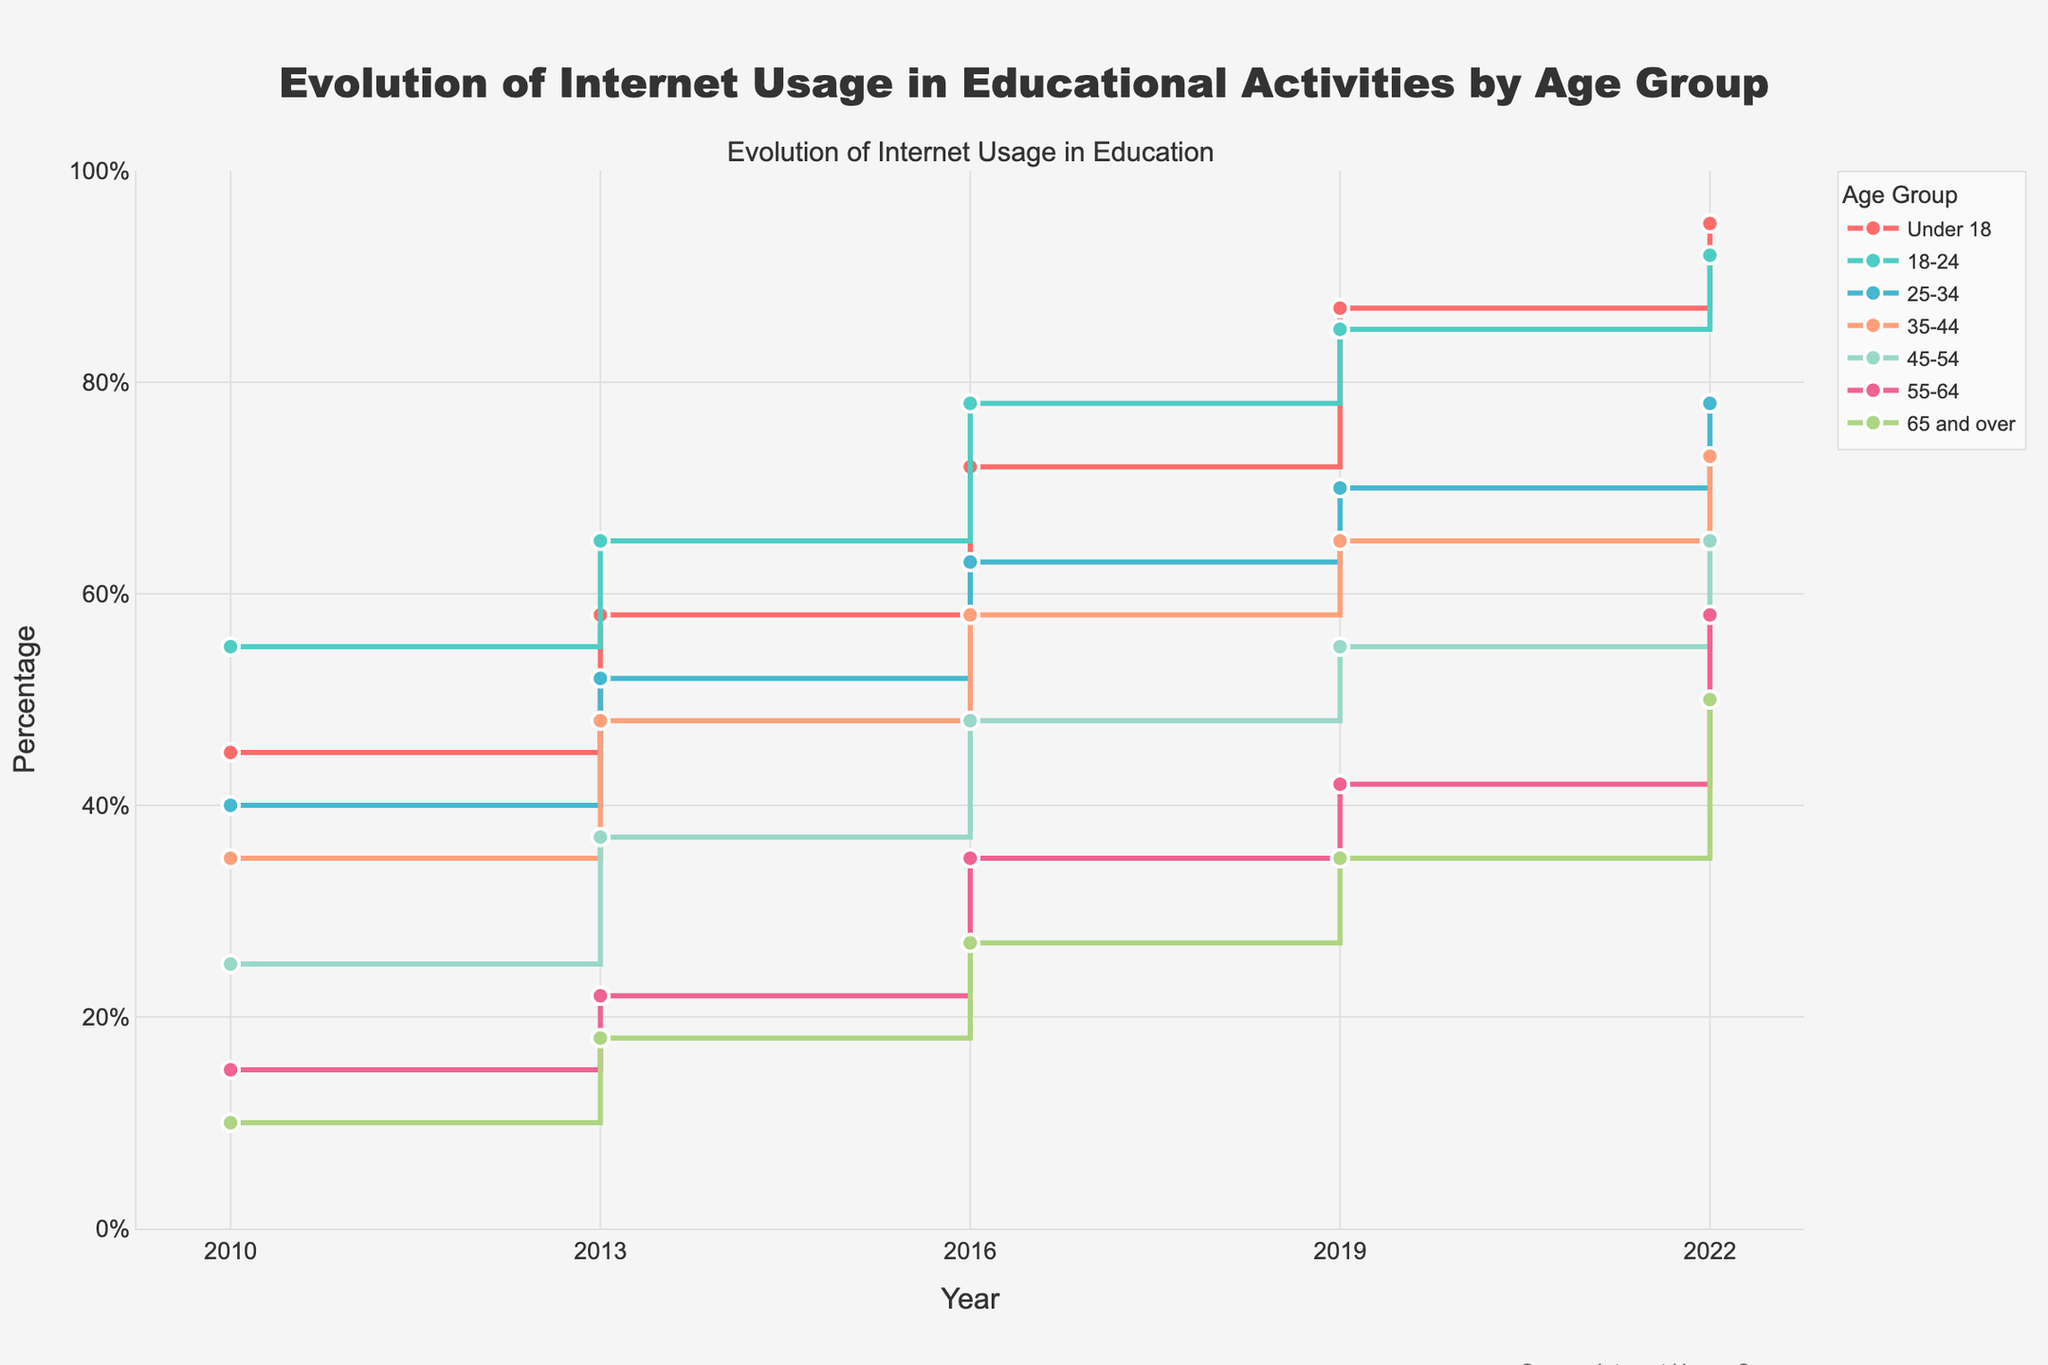What is the title of the plot? The title is located at the top center of the plot. It reads "Evolution of Internet Usage in Educational Activities by Age Group".
Answer: Evolution of Internet Usage in Educational Activities by Age Group What does the y-axis represent? The y-axis represents the percentage of internet usage in educational activities. This is indicated by the y-axis title "Percentage".
Answer: Percentage Which age group had the highest internet usage in 2010? To find this, look at the year 2010 on the x-axis and compare the percentage values for all age groups. The age group 18-24 had the highest percentage at 55%.
Answer: 18-24 How did internet usage change for the age group 25-34 from 2010 to 2022? Find the year 2010 and 2022 on the x-axis and look at the percentages for the age group 25-34. In 2010, it was 40%, and in 2022, it rose to 78%. The change is 78% - 40% = 38%.
Answer: Increased by 38% Which age group had the lowest internet usage in 2019, and what was the percentage? Look at the year 2019 on the x-axis and compare the percentages for all age groups. The age group 65 and over had the lowest percentage at 35%.
Answer: 65 and over with 35% What is the overall trend in internet usage for the age group 55-64 from 2010 to 2022? Find the percentages for the age group 55-64 in each year: 2010 (15%), 2013 (22%), 2016 (35%), 2019 (42%), 2022 (58%). The overall trend shows a continuous increase in internet usage for this age group.
Answer: Increasing In which year did the age group Under 18 surpass 70% in internet usage? Look at the percentages for the age group Under 18. They surpass 70% in 2016 with a percentage of 72%.
Answer: 2016 Between 2013 and 2016, which age group saw the highest increase in internet usage, and what was the increase? Calculate the difference in percentages between 2013 and 2016 for each age group. For Under 18, the increase is 72% - 58% = 14%. For 18-24, it's 78% - 65% = 13%. For 25-34, it's 63% - 52% = 11%. For 35-44, it's 58% - 48% = 10%. For 45-54, it's 48% - 37% = 11%. For 55-64, it's 35% - 22% = 13%. For 65 and over, it's 27% - 18% = 9%. The Under 18 group had the highest increase of 14%.
Answer: Under 18 with 14% What’s the average internet usage for the 25-34 age group across all years? Sum the percentages for the 25-34 age group across all years: 40% + 52% + 63% + 70% + 78% = 303%. There are 5 data points, so the average is 303% / 5 = 60.6%.
Answer: 60.6% Which age group has shown the least relative increase in internet usage from 2010 to 2022? Calculate the relative increase for each age group by dividing the difference between 2022 and 2010 percentages by the 2010 percentage. Under 18: (95% - 45%) / 45% = 1.11 (111%), 18-24: (92% - 55%) / 55% = 0.673 (67.3%), 25-34: (78% - 40%) / 40% = 0.95 (95%), 35-44: (73% - 35%) / 35% = 1.086 (108.6%), 45-54: (65% - 25%) / 25% = 1.6 (160%), 55-64: (58% - 15%) / 15% = 2.867 (286.7%), 65 and over: (50% - 10%) / 10% = 4 (400%). The 18-24 group has shown the least relative increase of 67.3%.
Answer: 18-24 